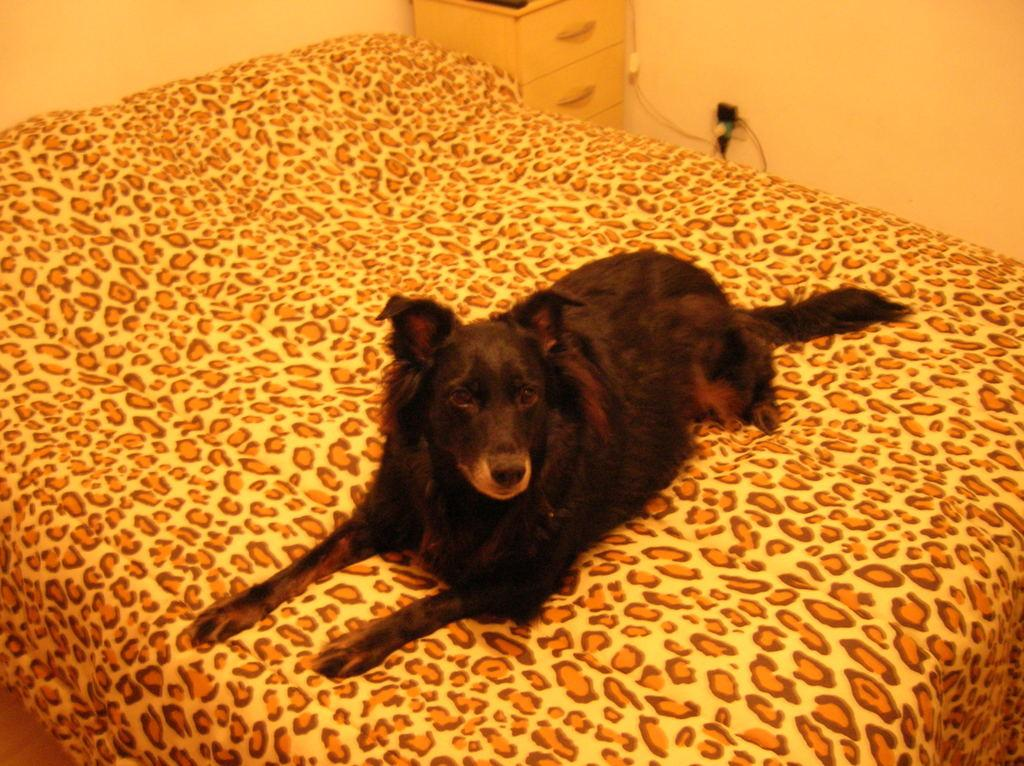What is the main object in the image? There is a bed in the image. What is on the bed? There is a dog on the bed. What is the color of the dog? The dog is black in color. What can be seen in the background of the image? There are drawers in the background of the image. What is near the switchboard in the image? There are wires near the switchboard in the image. What is the dog thinking in the image? The image does not show the dog's thoughts, so it cannot be determined from the image. 